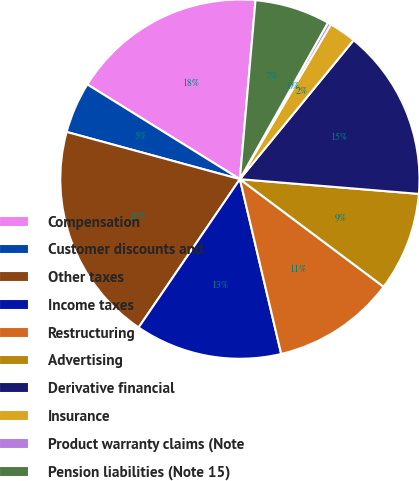Convert chart to OTSL. <chart><loc_0><loc_0><loc_500><loc_500><pie_chart><fcel>Compensation<fcel>Customer discounts and<fcel>Other taxes<fcel>Income taxes<fcel>Restructuring<fcel>Advertising<fcel>Derivative financial<fcel>Insurance<fcel>Product warranty claims (Note<fcel>Pension liabilities (Note 15)<nl><fcel>17.54%<fcel>4.61%<fcel>19.7%<fcel>13.23%<fcel>11.08%<fcel>8.92%<fcel>15.39%<fcel>2.46%<fcel>0.3%<fcel>6.77%<nl></chart> 